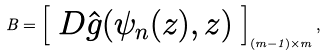Convert formula to latex. <formula><loc_0><loc_0><loc_500><loc_500>B = \left [ \begin{array} { c } D \hat { g } ( \psi _ { n } ( z ) , z ) \end{array} \right ] _ { ( m - 1 ) \times m } ,</formula> 